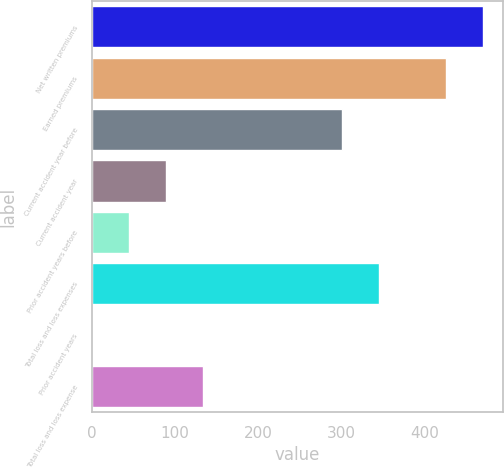<chart> <loc_0><loc_0><loc_500><loc_500><bar_chart><fcel>Net written premiums<fcel>Earned premiums<fcel>Current accident year before<fcel>Current accident year<fcel>Prior accident years before<fcel>Total loss and loss expenses<fcel>Prior accident years<fcel>Total loss and loss expense<nl><fcel>470.38<fcel>426<fcel>301<fcel>88.96<fcel>44.58<fcel>345.38<fcel>0.2<fcel>133.34<nl></chart> 